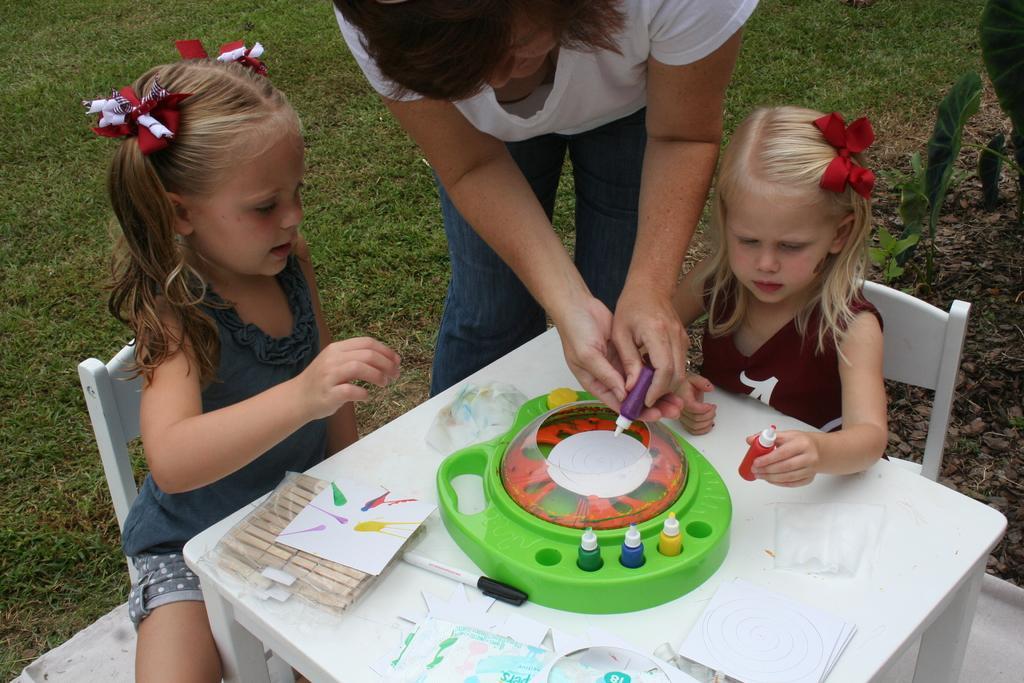Can you describe this image briefly? There are two girls, sitting on chairs in front of a table, on which, there is a green color object, there are papers, sketch and other objects. Beside the table, there is a woman in white color t-shirt, holding an object and standing on the grass on the ground. In the background, there is a plants and stones 